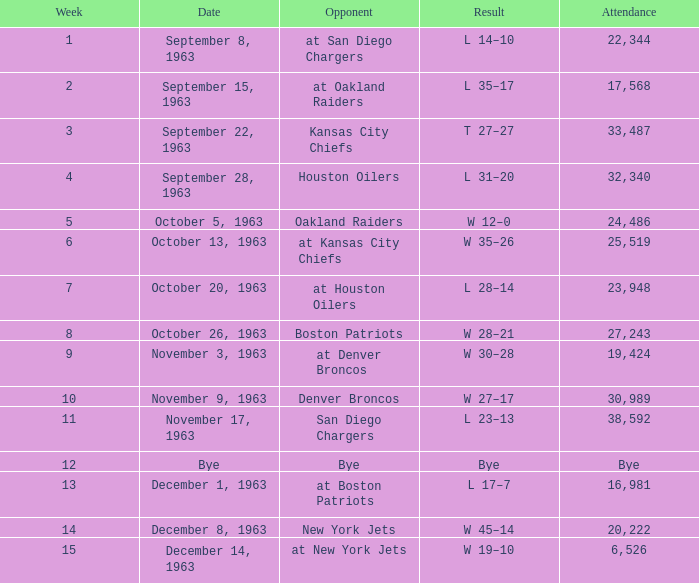Which rival has a result of 14-10? At san diego chargers. 